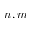Convert formula to latex. <formula><loc_0><loc_0><loc_500><loc_500>n , m</formula> 